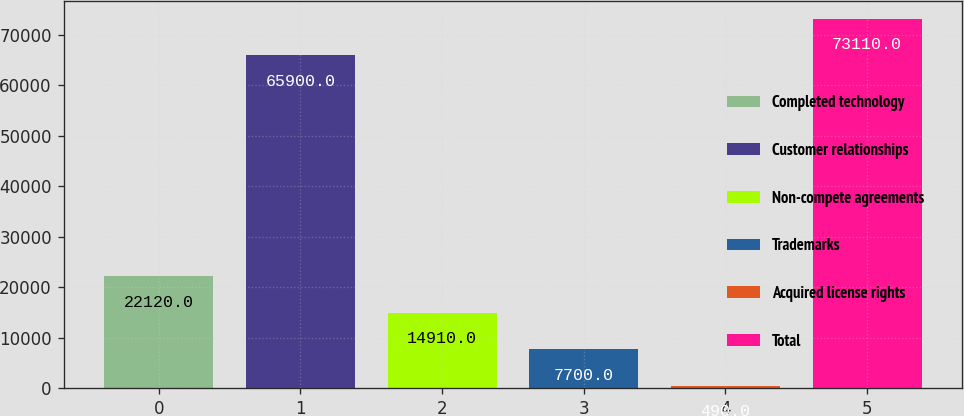<chart> <loc_0><loc_0><loc_500><loc_500><bar_chart><fcel>Completed technology<fcel>Customer relationships<fcel>Non-compete agreements<fcel>Trademarks<fcel>Acquired license rights<fcel>Total<nl><fcel>22120<fcel>65900<fcel>14910<fcel>7700<fcel>490<fcel>73110<nl></chart> 